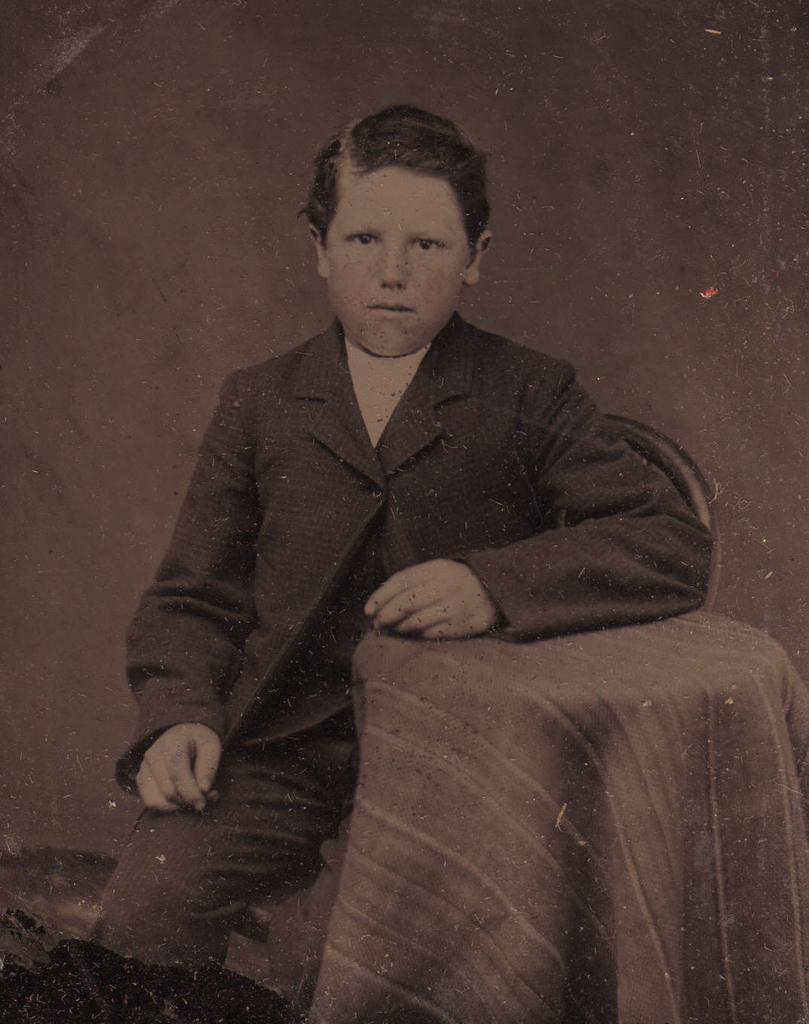What is the color scheme of the image? The image is black and white. What is the boy in the image doing? The boy is sitting on a chair. What can be seen in the background of the image? There is a wall in the background. Can you describe the table in the image? It appears that there is a table covered with a cloth in the image. What type of sugar is being used by the boy in the image? There is no sugar present in the image, as it features a boy sitting on a chair with a wall in the background and a table covered with a cloth. What hobbies does the boy have, as seen in the image? The image does not provide any information about the boy's hobbies. Is the boy holding an umbrella in the image? There is no umbrella present in the image. 